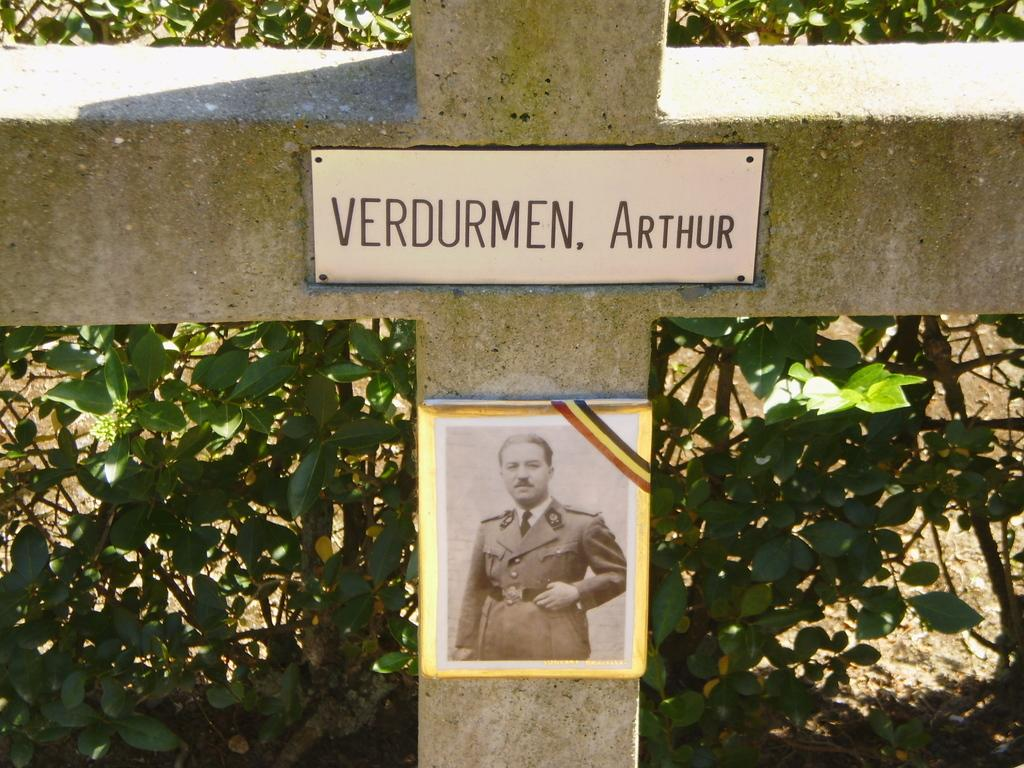What is the main feature in the center of the image? There is a wall in the center of the image. What is written on the board that is attached to the wall? There is text written on a board on the wall. What can be seen behind the wall in the image? There are plants visible behind the wall. How many members of the family are visible in the image? There is no family present in the image; it only features a wall, a board with text, and plants. What type of cap is the person wearing in the image? There is no person wearing a cap in the image. 